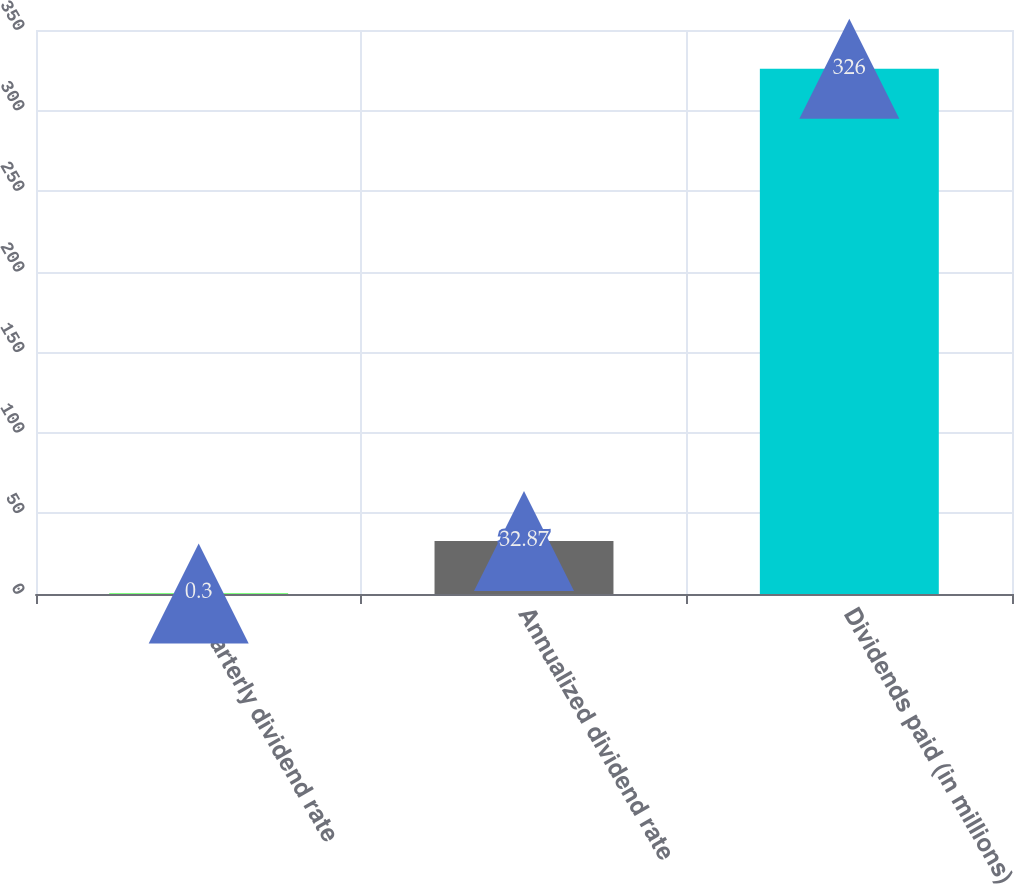Convert chart. <chart><loc_0><loc_0><loc_500><loc_500><bar_chart><fcel>Quarterly dividend rate<fcel>Annualized dividend rate<fcel>Dividends paid (in millions)<nl><fcel>0.3<fcel>32.87<fcel>326<nl></chart> 